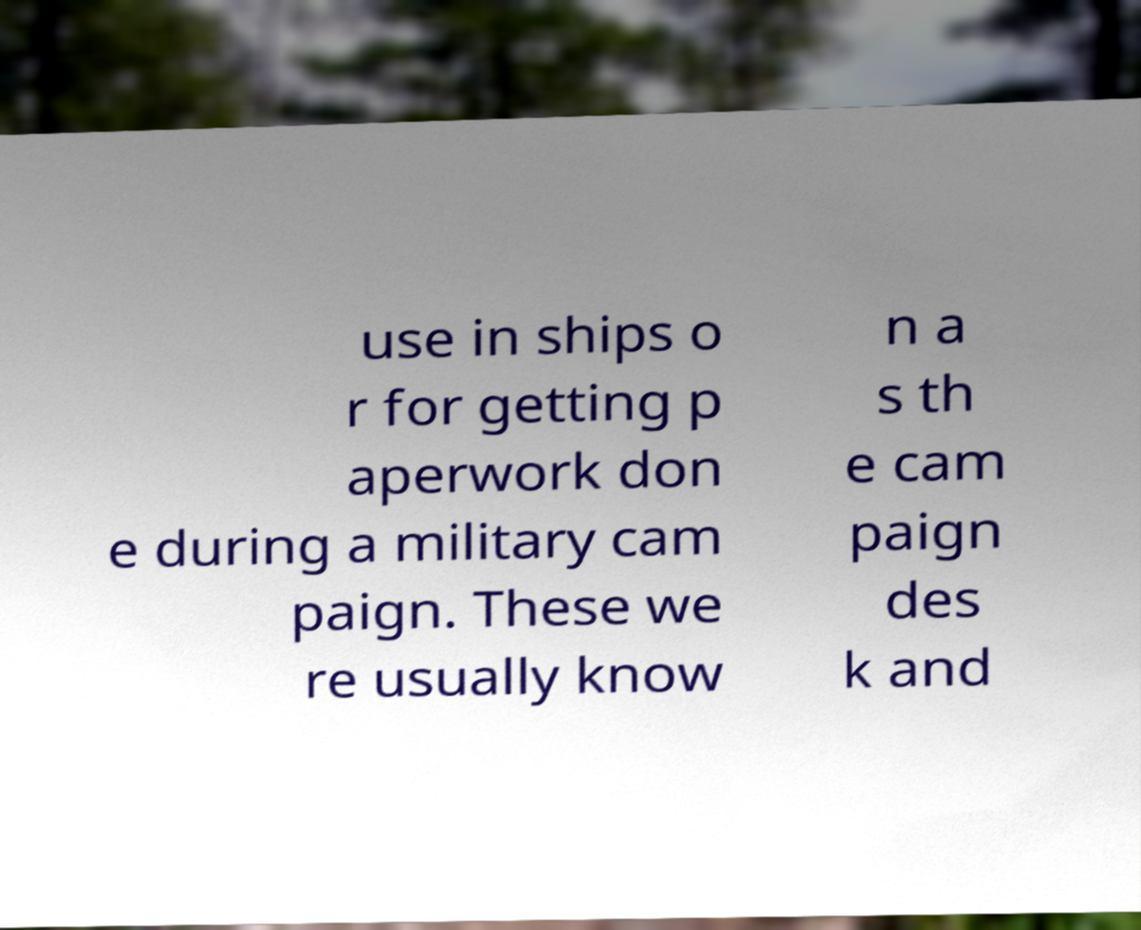Can you accurately transcribe the text from the provided image for me? use in ships o r for getting p aperwork don e during a military cam paign. These we re usually know n a s th e cam paign des k and 